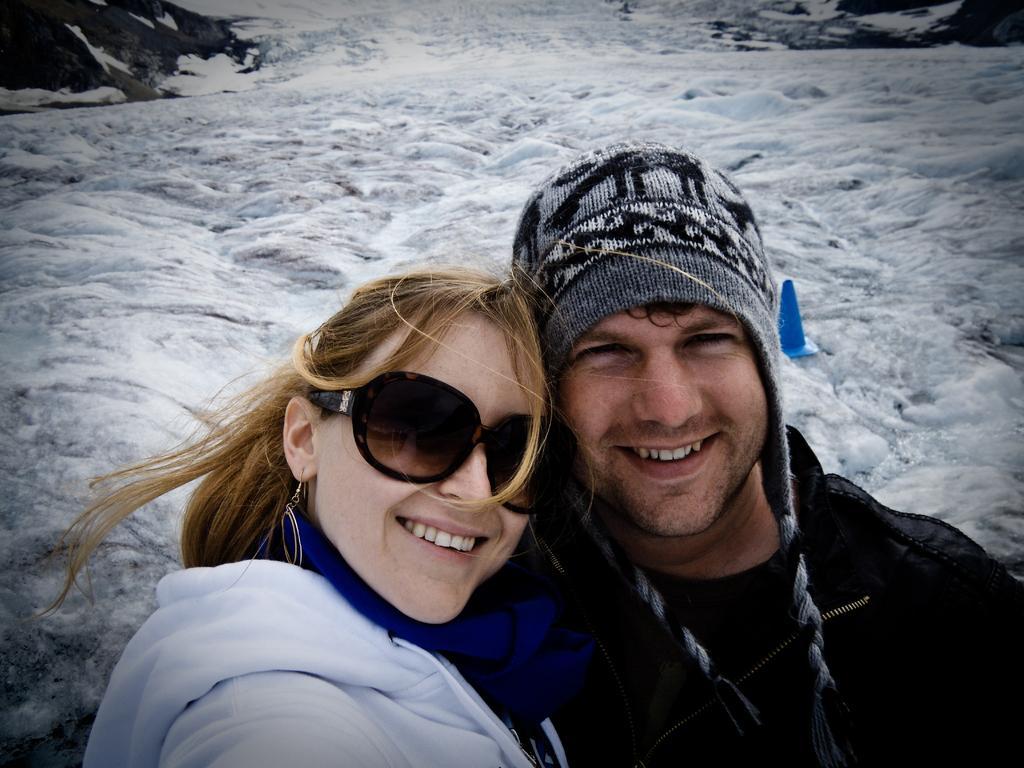Could you give a brief overview of what you see in this image? In this picture we can observe a couple. Both of them are smiling. There is a cap on the head of the man. The woman is wearing a white color hoodie and spectacles. In the background there is a river flowing. 